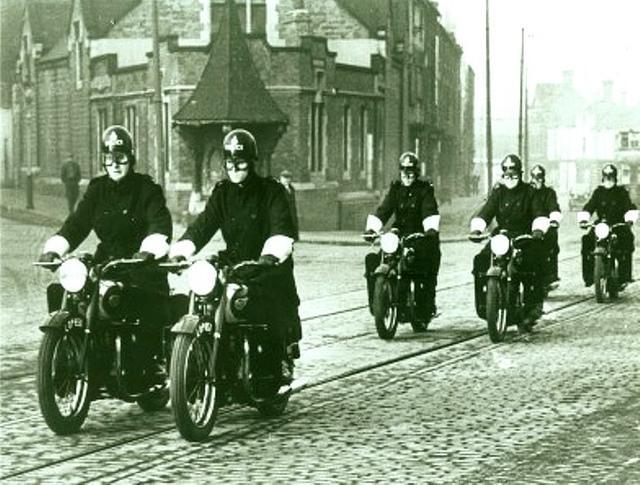How many people are there?
Give a very brief answer. 5. How many motorcycles can you see?
Give a very brief answer. 5. 